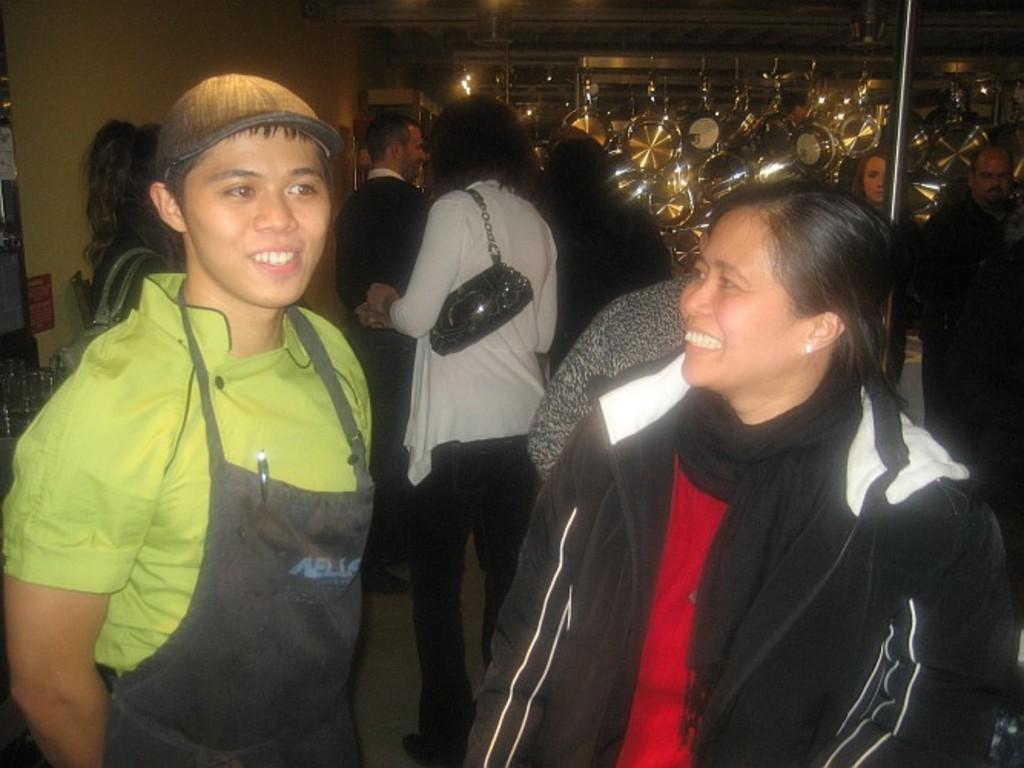Please provide a concise description of this image. In this image we can see a few people there are some pans, there is a pole, also we can see the sky. 